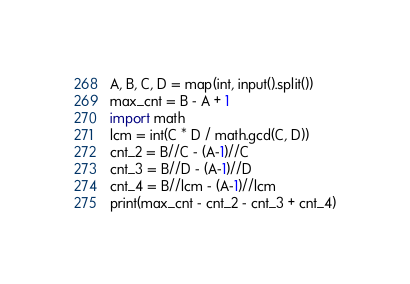Convert code to text. <code><loc_0><loc_0><loc_500><loc_500><_Python_>A, B, C, D = map(int, input().split())
max_cnt = B - A + 1
import math
lcm = int(C * D / math.gcd(C, D))
cnt_2 = B//C - (A-1)//C
cnt_3 = B//D - (A-1)//D
cnt_4 = B//lcm - (A-1)//lcm
print(max_cnt - cnt_2 - cnt_3 + cnt_4)</code> 